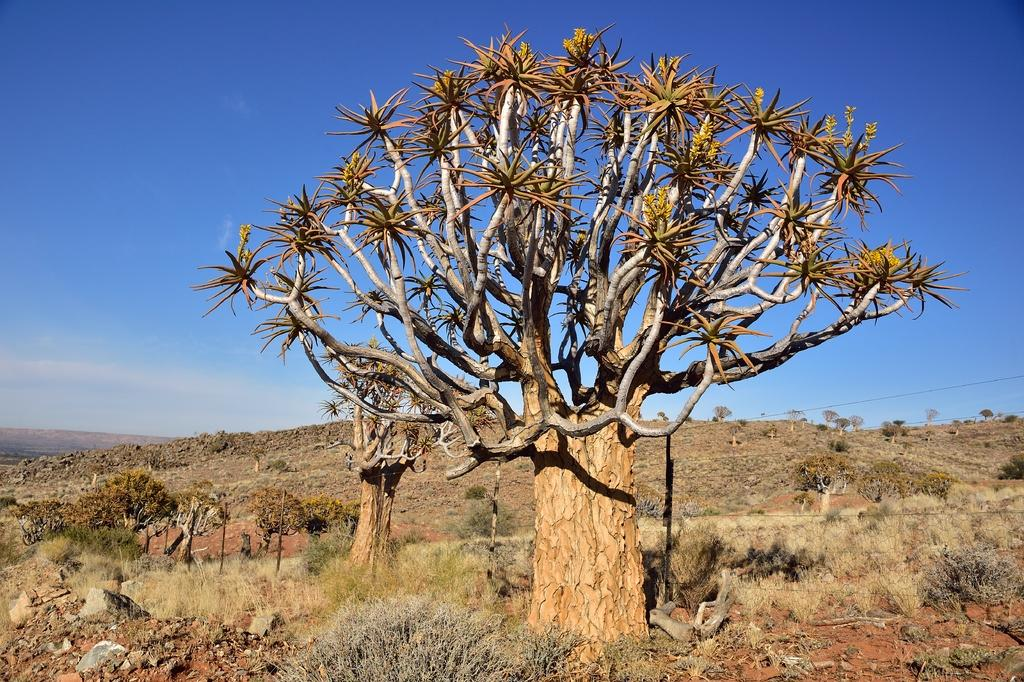What type of vegetation can be seen in the image? There are trees in the image. What structures are present in the image? There are poles in the image. What can be found on the ground in the image? There are stones on the ground in the image. What is visible in the background of the image? The sky is visible in the background of the image. Can you describe the steam coming from the plough in the image? There is no steam or plough present in the image. What type of day is depicted in the image? The provided facts do not mention the time of day or weather conditions, so it cannot be determined from the image. 